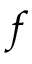Convert formula to latex. <formula><loc_0><loc_0><loc_500><loc_500>f</formula> 